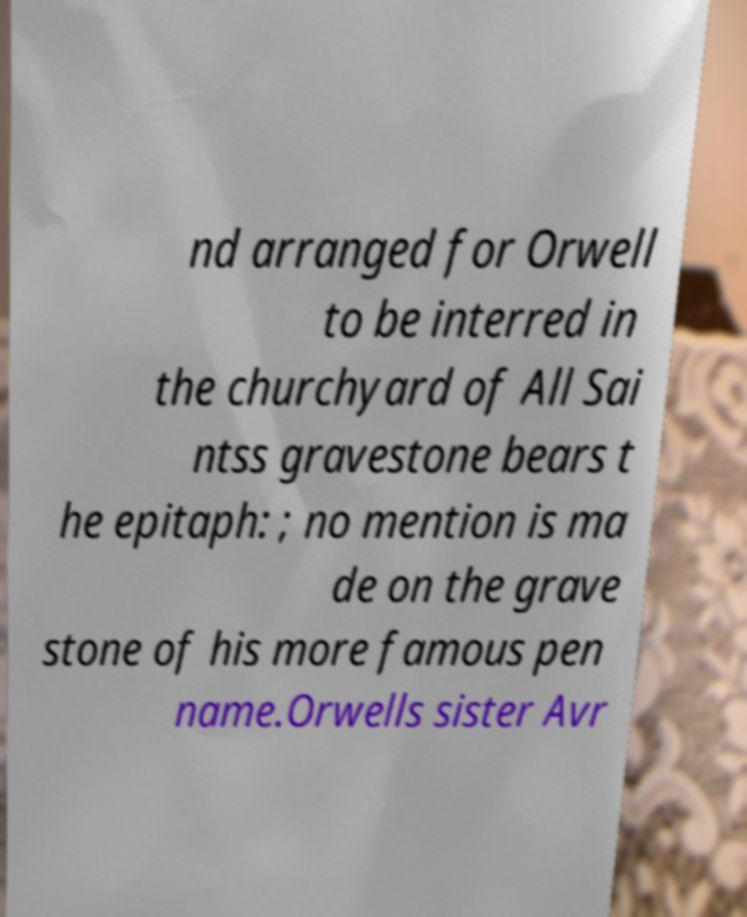There's text embedded in this image that I need extracted. Can you transcribe it verbatim? nd arranged for Orwell to be interred in the churchyard of All Sai ntss gravestone bears t he epitaph: ; no mention is ma de on the grave stone of his more famous pen name.Orwells sister Avr 